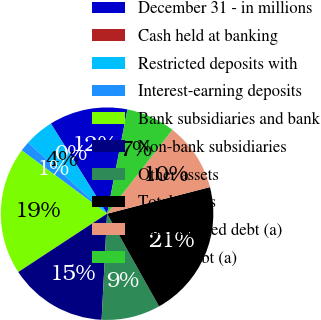Convert chart to OTSL. <chart><loc_0><loc_0><loc_500><loc_500><pie_chart><fcel>December 31 - in millions<fcel>Cash held at banking<fcel>Restricted deposits with<fcel>Interest-earning deposits<fcel>Bank subsidiaries and bank<fcel>Non-bank subsidiaries<fcel>Other assets<fcel>Total assets<fcel>Subordinated debt (a)<fcel>Senior debt (a)<nl><fcel>11.94%<fcel>0.0%<fcel>4.48%<fcel>1.49%<fcel>19.4%<fcel>14.93%<fcel>8.96%<fcel>20.89%<fcel>10.45%<fcel>7.46%<nl></chart> 